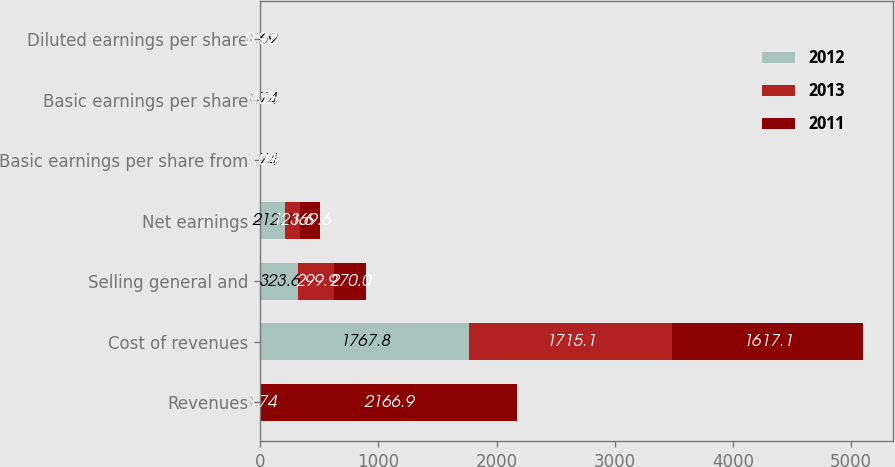<chart> <loc_0><loc_0><loc_500><loc_500><stacked_bar_chart><ecel><fcel>Revenues<fcel>Cost of revenues<fcel>Selling general and<fcel>Net earnings<fcel>Basic earnings per share from<fcel>Basic earnings per share<fcel>Diluted earnings per share<nl><fcel>2012<fcel>1.74<fcel>1767.8<fcel>323.6<fcel>212.1<fcel>1.74<fcel>1.74<fcel>1.69<nl><fcel>2013<fcel>1.74<fcel>1715.1<fcel>299.9<fcel>123.6<fcel>1.01<fcel>1<fcel>0.97<nl><fcel>2011<fcel>2166.9<fcel>1617.1<fcel>270<fcel>169.6<fcel>1.38<fcel>1.36<fcel>1.32<nl></chart> 